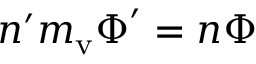Convert formula to latex. <formula><loc_0><loc_0><loc_500><loc_500>n ^ { \prime } m _ { v } \boldsymbol \Phi ^ { \prime } = n \boldsymbol \Phi</formula> 